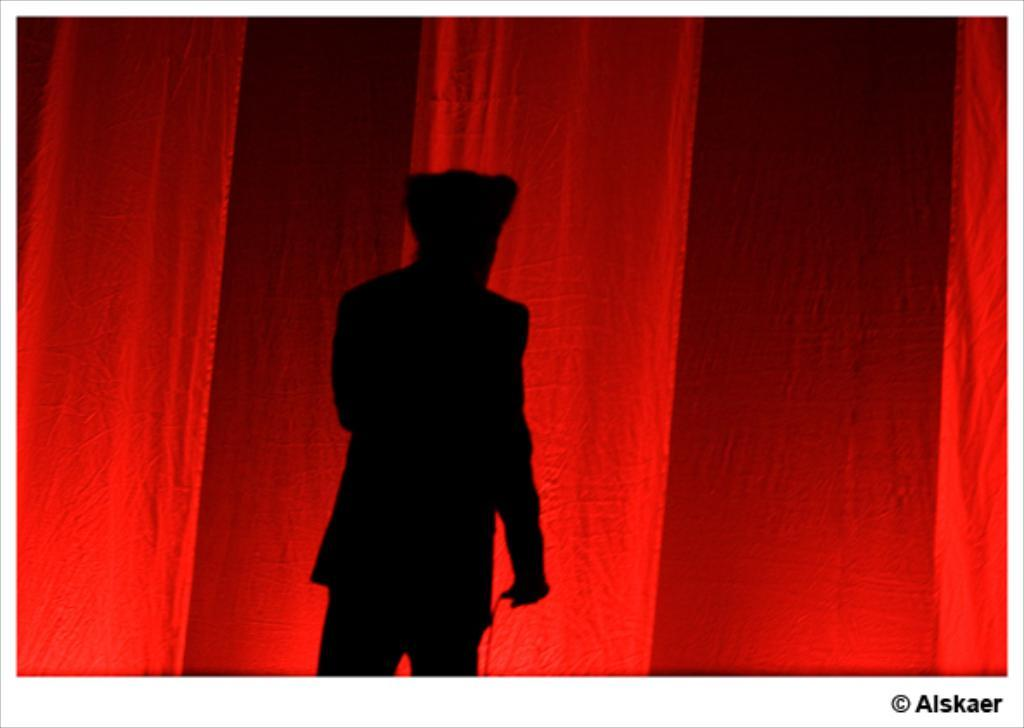What can be seen in the image that resembles a person? There is a shadow of a person in the image. What color is the cloth that is visible in the image? There is a red cloth in the image. What is the nature of the text or symbols present in the image? There is writing on the image. How many boats are visible in the image? There are no boats present in the image. What page of the book is the person reading in the image? There is no book or person reading in the image; it only features a shadow of a person and a red cloth. 